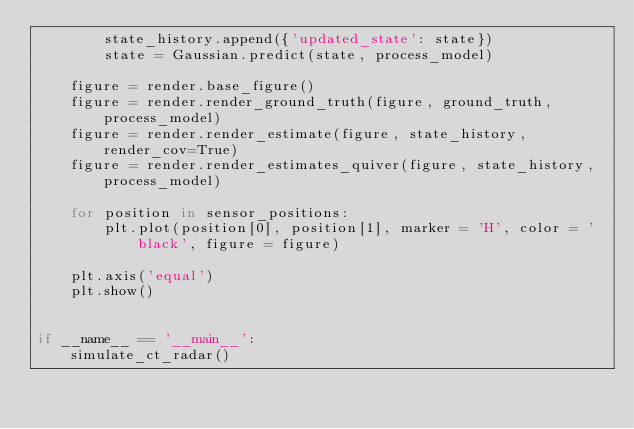<code> <loc_0><loc_0><loc_500><loc_500><_Python_>        state_history.append({'updated_state': state})
        state = Gaussian.predict(state, process_model)

    figure = render.base_figure()
    figure = render.render_ground_truth(figure, ground_truth, process_model)
    figure = render.render_estimate(figure, state_history, render_cov=True)
    figure = render.render_estimates_quiver(figure, state_history, process_model)

    for position in sensor_positions:
        plt.plot(position[0], position[1], marker = 'H', color = 'black', figure = figure)
    
    plt.axis('equal')
    plt.show()


if __name__ == '__main__':
    simulate_ct_radar()</code> 